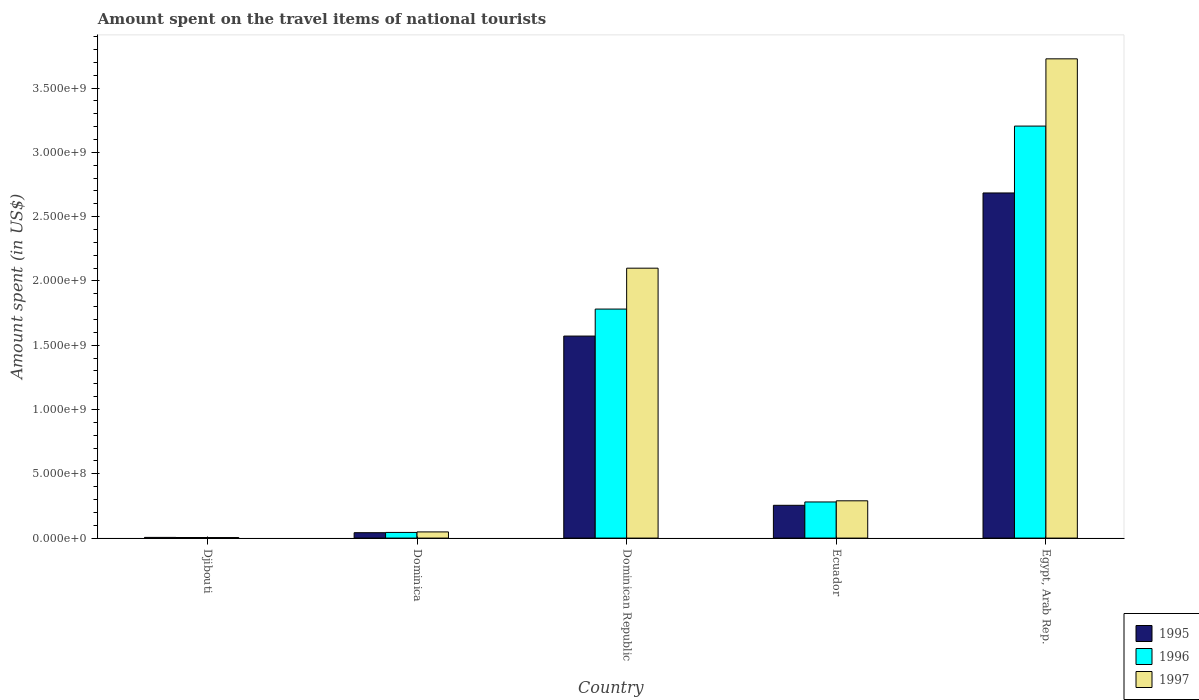How many bars are there on the 5th tick from the left?
Keep it short and to the point. 3. How many bars are there on the 5th tick from the right?
Your answer should be very brief. 3. What is the label of the 2nd group of bars from the left?
Ensure brevity in your answer.  Dominica. What is the amount spent on the travel items of national tourists in 1995 in Egypt, Arab Rep.?
Ensure brevity in your answer.  2.68e+09. Across all countries, what is the maximum amount spent on the travel items of national tourists in 1997?
Your answer should be compact. 3.73e+09. Across all countries, what is the minimum amount spent on the travel items of national tourists in 1996?
Your answer should be very brief. 4.60e+06. In which country was the amount spent on the travel items of national tourists in 1995 maximum?
Offer a terse response. Egypt, Arab Rep. In which country was the amount spent on the travel items of national tourists in 1996 minimum?
Offer a terse response. Djibouti. What is the total amount spent on the travel items of national tourists in 1997 in the graph?
Provide a short and direct response. 6.17e+09. What is the difference between the amount spent on the travel items of national tourists in 1997 in Dominica and that in Ecuador?
Provide a succinct answer. -2.42e+08. What is the difference between the amount spent on the travel items of national tourists in 1996 in Ecuador and the amount spent on the travel items of national tourists in 1995 in Egypt, Arab Rep.?
Your answer should be very brief. -2.40e+09. What is the average amount spent on the travel items of national tourists in 1996 per country?
Your answer should be very brief. 1.06e+09. What is the difference between the amount spent on the travel items of national tourists of/in 1995 and amount spent on the travel items of national tourists of/in 1996 in Ecuador?
Offer a terse response. -2.60e+07. What is the ratio of the amount spent on the travel items of national tourists in 1996 in Dominica to that in Dominican Republic?
Your response must be concise. 0.02. Is the amount spent on the travel items of national tourists in 1995 in Dominican Republic less than that in Ecuador?
Your answer should be compact. No. What is the difference between the highest and the second highest amount spent on the travel items of national tourists in 1995?
Ensure brevity in your answer.  2.43e+09. What is the difference between the highest and the lowest amount spent on the travel items of national tourists in 1997?
Provide a succinct answer. 3.72e+09. In how many countries, is the amount spent on the travel items of national tourists in 1995 greater than the average amount spent on the travel items of national tourists in 1995 taken over all countries?
Give a very brief answer. 2. What does the 1st bar from the left in Dominica represents?
Provide a short and direct response. 1995. How many bars are there?
Keep it short and to the point. 15. What is the difference between two consecutive major ticks on the Y-axis?
Your answer should be very brief. 5.00e+08. Where does the legend appear in the graph?
Keep it short and to the point. Bottom right. How are the legend labels stacked?
Offer a terse response. Vertical. What is the title of the graph?
Your answer should be compact. Amount spent on the travel items of national tourists. Does "2013" appear as one of the legend labels in the graph?
Offer a terse response. No. What is the label or title of the X-axis?
Offer a terse response. Country. What is the label or title of the Y-axis?
Offer a terse response. Amount spent (in US$). What is the Amount spent (in US$) in 1995 in Djibouti?
Offer a very short reply. 5.40e+06. What is the Amount spent (in US$) of 1996 in Djibouti?
Your response must be concise. 4.60e+06. What is the Amount spent (in US$) of 1997 in Djibouti?
Give a very brief answer. 4.20e+06. What is the Amount spent (in US$) in 1995 in Dominica?
Your answer should be compact. 4.20e+07. What is the Amount spent (in US$) in 1996 in Dominica?
Offer a very short reply. 4.40e+07. What is the Amount spent (in US$) of 1997 in Dominica?
Keep it short and to the point. 4.80e+07. What is the Amount spent (in US$) of 1995 in Dominican Republic?
Your response must be concise. 1.57e+09. What is the Amount spent (in US$) in 1996 in Dominican Republic?
Your answer should be compact. 1.78e+09. What is the Amount spent (in US$) of 1997 in Dominican Republic?
Give a very brief answer. 2.10e+09. What is the Amount spent (in US$) in 1995 in Ecuador?
Provide a succinct answer. 2.55e+08. What is the Amount spent (in US$) in 1996 in Ecuador?
Offer a terse response. 2.81e+08. What is the Amount spent (in US$) of 1997 in Ecuador?
Offer a very short reply. 2.90e+08. What is the Amount spent (in US$) of 1995 in Egypt, Arab Rep.?
Offer a terse response. 2.68e+09. What is the Amount spent (in US$) in 1996 in Egypt, Arab Rep.?
Your response must be concise. 3.20e+09. What is the Amount spent (in US$) of 1997 in Egypt, Arab Rep.?
Give a very brief answer. 3.73e+09. Across all countries, what is the maximum Amount spent (in US$) of 1995?
Keep it short and to the point. 2.68e+09. Across all countries, what is the maximum Amount spent (in US$) in 1996?
Provide a succinct answer. 3.20e+09. Across all countries, what is the maximum Amount spent (in US$) of 1997?
Provide a short and direct response. 3.73e+09. Across all countries, what is the minimum Amount spent (in US$) in 1995?
Give a very brief answer. 5.40e+06. Across all countries, what is the minimum Amount spent (in US$) of 1996?
Make the answer very short. 4.60e+06. Across all countries, what is the minimum Amount spent (in US$) in 1997?
Provide a succinct answer. 4.20e+06. What is the total Amount spent (in US$) of 1995 in the graph?
Ensure brevity in your answer.  4.56e+09. What is the total Amount spent (in US$) in 1996 in the graph?
Give a very brief answer. 5.31e+09. What is the total Amount spent (in US$) in 1997 in the graph?
Your answer should be compact. 6.17e+09. What is the difference between the Amount spent (in US$) in 1995 in Djibouti and that in Dominica?
Your answer should be very brief. -3.66e+07. What is the difference between the Amount spent (in US$) in 1996 in Djibouti and that in Dominica?
Provide a succinct answer. -3.94e+07. What is the difference between the Amount spent (in US$) of 1997 in Djibouti and that in Dominica?
Provide a succinct answer. -4.38e+07. What is the difference between the Amount spent (in US$) in 1995 in Djibouti and that in Dominican Republic?
Your answer should be compact. -1.57e+09. What is the difference between the Amount spent (in US$) in 1996 in Djibouti and that in Dominican Republic?
Your answer should be compact. -1.78e+09. What is the difference between the Amount spent (in US$) in 1997 in Djibouti and that in Dominican Republic?
Offer a terse response. -2.09e+09. What is the difference between the Amount spent (in US$) in 1995 in Djibouti and that in Ecuador?
Offer a very short reply. -2.50e+08. What is the difference between the Amount spent (in US$) of 1996 in Djibouti and that in Ecuador?
Give a very brief answer. -2.76e+08. What is the difference between the Amount spent (in US$) of 1997 in Djibouti and that in Ecuador?
Ensure brevity in your answer.  -2.86e+08. What is the difference between the Amount spent (in US$) in 1995 in Djibouti and that in Egypt, Arab Rep.?
Offer a terse response. -2.68e+09. What is the difference between the Amount spent (in US$) in 1996 in Djibouti and that in Egypt, Arab Rep.?
Your response must be concise. -3.20e+09. What is the difference between the Amount spent (in US$) of 1997 in Djibouti and that in Egypt, Arab Rep.?
Give a very brief answer. -3.72e+09. What is the difference between the Amount spent (in US$) of 1995 in Dominica and that in Dominican Republic?
Offer a very short reply. -1.53e+09. What is the difference between the Amount spent (in US$) of 1996 in Dominica and that in Dominican Republic?
Offer a terse response. -1.74e+09. What is the difference between the Amount spent (in US$) of 1997 in Dominica and that in Dominican Republic?
Offer a very short reply. -2.05e+09. What is the difference between the Amount spent (in US$) in 1995 in Dominica and that in Ecuador?
Offer a very short reply. -2.13e+08. What is the difference between the Amount spent (in US$) in 1996 in Dominica and that in Ecuador?
Provide a short and direct response. -2.37e+08. What is the difference between the Amount spent (in US$) of 1997 in Dominica and that in Ecuador?
Give a very brief answer. -2.42e+08. What is the difference between the Amount spent (in US$) in 1995 in Dominica and that in Egypt, Arab Rep.?
Provide a short and direct response. -2.64e+09. What is the difference between the Amount spent (in US$) in 1996 in Dominica and that in Egypt, Arab Rep.?
Make the answer very short. -3.16e+09. What is the difference between the Amount spent (in US$) of 1997 in Dominica and that in Egypt, Arab Rep.?
Your answer should be compact. -3.68e+09. What is the difference between the Amount spent (in US$) in 1995 in Dominican Republic and that in Ecuador?
Give a very brief answer. 1.32e+09. What is the difference between the Amount spent (in US$) in 1996 in Dominican Republic and that in Ecuador?
Offer a very short reply. 1.50e+09. What is the difference between the Amount spent (in US$) in 1997 in Dominican Republic and that in Ecuador?
Your answer should be compact. 1.81e+09. What is the difference between the Amount spent (in US$) in 1995 in Dominican Republic and that in Egypt, Arab Rep.?
Your response must be concise. -1.11e+09. What is the difference between the Amount spent (in US$) of 1996 in Dominican Republic and that in Egypt, Arab Rep.?
Your answer should be compact. -1.42e+09. What is the difference between the Amount spent (in US$) of 1997 in Dominican Republic and that in Egypt, Arab Rep.?
Ensure brevity in your answer.  -1.63e+09. What is the difference between the Amount spent (in US$) in 1995 in Ecuador and that in Egypt, Arab Rep.?
Offer a very short reply. -2.43e+09. What is the difference between the Amount spent (in US$) of 1996 in Ecuador and that in Egypt, Arab Rep.?
Your answer should be compact. -2.92e+09. What is the difference between the Amount spent (in US$) of 1997 in Ecuador and that in Egypt, Arab Rep.?
Give a very brief answer. -3.44e+09. What is the difference between the Amount spent (in US$) of 1995 in Djibouti and the Amount spent (in US$) of 1996 in Dominica?
Ensure brevity in your answer.  -3.86e+07. What is the difference between the Amount spent (in US$) of 1995 in Djibouti and the Amount spent (in US$) of 1997 in Dominica?
Offer a terse response. -4.26e+07. What is the difference between the Amount spent (in US$) in 1996 in Djibouti and the Amount spent (in US$) in 1997 in Dominica?
Keep it short and to the point. -4.34e+07. What is the difference between the Amount spent (in US$) in 1995 in Djibouti and the Amount spent (in US$) in 1996 in Dominican Republic?
Give a very brief answer. -1.78e+09. What is the difference between the Amount spent (in US$) of 1995 in Djibouti and the Amount spent (in US$) of 1997 in Dominican Republic?
Your answer should be very brief. -2.09e+09. What is the difference between the Amount spent (in US$) of 1996 in Djibouti and the Amount spent (in US$) of 1997 in Dominican Republic?
Provide a short and direct response. -2.09e+09. What is the difference between the Amount spent (in US$) in 1995 in Djibouti and the Amount spent (in US$) in 1996 in Ecuador?
Your response must be concise. -2.76e+08. What is the difference between the Amount spent (in US$) of 1995 in Djibouti and the Amount spent (in US$) of 1997 in Ecuador?
Offer a very short reply. -2.85e+08. What is the difference between the Amount spent (in US$) in 1996 in Djibouti and the Amount spent (in US$) in 1997 in Ecuador?
Offer a terse response. -2.85e+08. What is the difference between the Amount spent (in US$) in 1995 in Djibouti and the Amount spent (in US$) in 1996 in Egypt, Arab Rep.?
Keep it short and to the point. -3.20e+09. What is the difference between the Amount spent (in US$) of 1995 in Djibouti and the Amount spent (in US$) of 1997 in Egypt, Arab Rep.?
Keep it short and to the point. -3.72e+09. What is the difference between the Amount spent (in US$) in 1996 in Djibouti and the Amount spent (in US$) in 1997 in Egypt, Arab Rep.?
Your answer should be compact. -3.72e+09. What is the difference between the Amount spent (in US$) in 1995 in Dominica and the Amount spent (in US$) in 1996 in Dominican Republic?
Ensure brevity in your answer.  -1.74e+09. What is the difference between the Amount spent (in US$) of 1995 in Dominica and the Amount spent (in US$) of 1997 in Dominican Republic?
Your answer should be very brief. -2.06e+09. What is the difference between the Amount spent (in US$) in 1996 in Dominica and the Amount spent (in US$) in 1997 in Dominican Republic?
Make the answer very short. -2.06e+09. What is the difference between the Amount spent (in US$) of 1995 in Dominica and the Amount spent (in US$) of 1996 in Ecuador?
Your answer should be compact. -2.39e+08. What is the difference between the Amount spent (in US$) in 1995 in Dominica and the Amount spent (in US$) in 1997 in Ecuador?
Your answer should be very brief. -2.48e+08. What is the difference between the Amount spent (in US$) of 1996 in Dominica and the Amount spent (in US$) of 1997 in Ecuador?
Offer a terse response. -2.46e+08. What is the difference between the Amount spent (in US$) in 1995 in Dominica and the Amount spent (in US$) in 1996 in Egypt, Arab Rep.?
Give a very brief answer. -3.16e+09. What is the difference between the Amount spent (in US$) in 1995 in Dominica and the Amount spent (in US$) in 1997 in Egypt, Arab Rep.?
Your answer should be very brief. -3.68e+09. What is the difference between the Amount spent (in US$) in 1996 in Dominica and the Amount spent (in US$) in 1997 in Egypt, Arab Rep.?
Provide a short and direct response. -3.68e+09. What is the difference between the Amount spent (in US$) in 1995 in Dominican Republic and the Amount spent (in US$) in 1996 in Ecuador?
Your response must be concise. 1.29e+09. What is the difference between the Amount spent (in US$) in 1995 in Dominican Republic and the Amount spent (in US$) in 1997 in Ecuador?
Your answer should be very brief. 1.28e+09. What is the difference between the Amount spent (in US$) in 1996 in Dominican Republic and the Amount spent (in US$) in 1997 in Ecuador?
Offer a terse response. 1.49e+09. What is the difference between the Amount spent (in US$) of 1995 in Dominican Republic and the Amount spent (in US$) of 1996 in Egypt, Arab Rep.?
Ensure brevity in your answer.  -1.63e+09. What is the difference between the Amount spent (in US$) in 1995 in Dominican Republic and the Amount spent (in US$) in 1997 in Egypt, Arab Rep.?
Your answer should be very brief. -2.16e+09. What is the difference between the Amount spent (in US$) in 1996 in Dominican Republic and the Amount spent (in US$) in 1997 in Egypt, Arab Rep.?
Your response must be concise. -1.95e+09. What is the difference between the Amount spent (in US$) in 1995 in Ecuador and the Amount spent (in US$) in 1996 in Egypt, Arab Rep.?
Provide a short and direct response. -2.95e+09. What is the difference between the Amount spent (in US$) of 1995 in Ecuador and the Amount spent (in US$) of 1997 in Egypt, Arab Rep.?
Offer a very short reply. -3.47e+09. What is the difference between the Amount spent (in US$) in 1996 in Ecuador and the Amount spent (in US$) in 1997 in Egypt, Arab Rep.?
Provide a succinct answer. -3.45e+09. What is the average Amount spent (in US$) of 1995 per country?
Keep it short and to the point. 9.11e+08. What is the average Amount spent (in US$) of 1996 per country?
Offer a very short reply. 1.06e+09. What is the average Amount spent (in US$) of 1997 per country?
Your answer should be very brief. 1.23e+09. What is the difference between the Amount spent (in US$) in 1995 and Amount spent (in US$) in 1997 in Djibouti?
Give a very brief answer. 1.20e+06. What is the difference between the Amount spent (in US$) in 1996 and Amount spent (in US$) in 1997 in Djibouti?
Ensure brevity in your answer.  4.00e+05. What is the difference between the Amount spent (in US$) in 1995 and Amount spent (in US$) in 1997 in Dominica?
Give a very brief answer. -6.00e+06. What is the difference between the Amount spent (in US$) of 1996 and Amount spent (in US$) of 1997 in Dominica?
Ensure brevity in your answer.  -4.00e+06. What is the difference between the Amount spent (in US$) in 1995 and Amount spent (in US$) in 1996 in Dominican Republic?
Keep it short and to the point. -2.10e+08. What is the difference between the Amount spent (in US$) in 1995 and Amount spent (in US$) in 1997 in Dominican Republic?
Ensure brevity in your answer.  -5.28e+08. What is the difference between the Amount spent (in US$) of 1996 and Amount spent (in US$) of 1997 in Dominican Republic?
Make the answer very short. -3.18e+08. What is the difference between the Amount spent (in US$) in 1995 and Amount spent (in US$) in 1996 in Ecuador?
Provide a succinct answer. -2.60e+07. What is the difference between the Amount spent (in US$) of 1995 and Amount spent (in US$) of 1997 in Ecuador?
Ensure brevity in your answer.  -3.50e+07. What is the difference between the Amount spent (in US$) in 1996 and Amount spent (in US$) in 1997 in Ecuador?
Your answer should be very brief. -9.00e+06. What is the difference between the Amount spent (in US$) in 1995 and Amount spent (in US$) in 1996 in Egypt, Arab Rep.?
Your answer should be very brief. -5.20e+08. What is the difference between the Amount spent (in US$) in 1995 and Amount spent (in US$) in 1997 in Egypt, Arab Rep.?
Your answer should be compact. -1.04e+09. What is the difference between the Amount spent (in US$) in 1996 and Amount spent (in US$) in 1997 in Egypt, Arab Rep.?
Ensure brevity in your answer.  -5.23e+08. What is the ratio of the Amount spent (in US$) in 1995 in Djibouti to that in Dominica?
Offer a very short reply. 0.13. What is the ratio of the Amount spent (in US$) in 1996 in Djibouti to that in Dominica?
Your answer should be compact. 0.1. What is the ratio of the Amount spent (in US$) in 1997 in Djibouti to that in Dominica?
Provide a succinct answer. 0.09. What is the ratio of the Amount spent (in US$) in 1995 in Djibouti to that in Dominican Republic?
Offer a terse response. 0. What is the ratio of the Amount spent (in US$) in 1996 in Djibouti to that in Dominican Republic?
Make the answer very short. 0. What is the ratio of the Amount spent (in US$) in 1997 in Djibouti to that in Dominican Republic?
Give a very brief answer. 0. What is the ratio of the Amount spent (in US$) in 1995 in Djibouti to that in Ecuador?
Give a very brief answer. 0.02. What is the ratio of the Amount spent (in US$) in 1996 in Djibouti to that in Ecuador?
Keep it short and to the point. 0.02. What is the ratio of the Amount spent (in US$) in 1997 in Djibouti to that in Ecuador?
Make the answer very short. 0.01. What is the ratio of the Amount spent (in US$) of 1995 in Djibouti to that in Egypt, Arab Rep.?
Offer a very short reply. 0. What is the ratio of the Amount spent (in US$) of 1996 in Djibouti to that in Egypt, Arab Rep.?
Offer a terse response. 0. What is the ratio of the Amount spent (in US$) in 1997 in Djibouti to that in Egypt, Arab Rep.?
Your response must be concise. 0. What is the ratio of the Amount spent (in US$) in 1995 in Dominica to that in Dominican Republic?
Your answer should be compact. 0.03. What is the ratio of the Amount spent (in US$) of 1996 in Dominica to that in Dominican Republic?
Offer a very short reply. 0.02. What is the ratio of the Amount spent (in US$) in 1997 in Dominica to that in Dominican Republic?
Provide a short and direct response. 0.02. What is the ratio of the Amount spent (in US$) in 1995 in Dominica to that in Ecuador?
Provide a short and direct response. 0.16. What is the ratio of the Amount spent (in US$) in 1996 in Dominica to that in Ecuador?
Make the answer very short. 0.16. What is the ratio of the Amount spent (in US$) of 1997 in Dominica to that in Ecuador?
Give a very brief answer. 0.17. What is the ratio of the Amount spent (in US$) of 1995 in Dominica to that in Egypt, Arab Rep.?
Your answer should be compact. 0.02. What is the ratio of the Amount spent (in US$) of 1996 in Dominica to that in Egypt, Arab Rep.?
Your response must be concise. 0.01. What is the ratio of the Amount spent (in US$) in 1997 in Dominica to that in Egypt, Arab Rep.?
Keep it short and to the point. 0.01. What is the ratio of the Amount spent (in US$) in 1995 in Dominican Republic to that in Ecuador?
Offer a terse response. 6.16. What is the ratio of the Amount spent (in US$) of 1996 in Dominican Republic to that in Ecuador?
Offer a very short reply. 6.34. What is the ratio of the Amount spent (in US$) of 1997 in Dominican Republic to that in Ecuador?
Your response must be concise. 7.24. What is the ratio of the Amount spent (in US$) of 1995 in Dominican Republic to that in Egypt, Arab Rep.?
Ensure brevity in your answer.  0.59. What is the ratio of the Amount spent (in US$) in 1996 in Dominican Republic to that in Egypt, Arab Rep.?
Offer a terse response. 0.56. What is the ratio of the Amount spent (in US$) of 1997 in Dominican Republic to that in Egypt, Arab Rep.?
Offer a very short reply. 0.56. What is the ratio of the Amount spent (in US$) of 1995 in Ecuador to that in Egypt, Arab Rep.?
Offer a very short reply. 0.1. What is the ratio of the Amount spent (in US$) in 1996 in Ecuador to that in Egypt, Arab Rep.?
Provide a succinct answer. 0.09. What is the ratio of the Amount spent (in US$) of 1997 in Ecuador to that in Egypt, Arab Rep.?
Provide a short and direct response. 0.08. What is the difference between the highest and the second highest Amount spent (in US$) of 1995?
Your response must be concise. 1.11e+09. What is the difference between the highest and the second highest Amount spent (in US$) of 1996?
Your response must be concise. 1.42e+09. What is the difference between the highest and the second highest Amount spent (in US$) of 1997?
Offer a very short reply. 1.63e+09. What is the difference between the highest and the lowest Amount spent (in US$) in 1995?
Ensure brevity in your answer.  2.68e+09. What is the difference between the highest and the lowest Amount spent (in US$) of 1996?
Make the answer very short. 3.20e+09. What is the difference between the highest and the lowest Amount spent (in US$) of 1997?
Your answer should be very brief. 3.72e+09. 